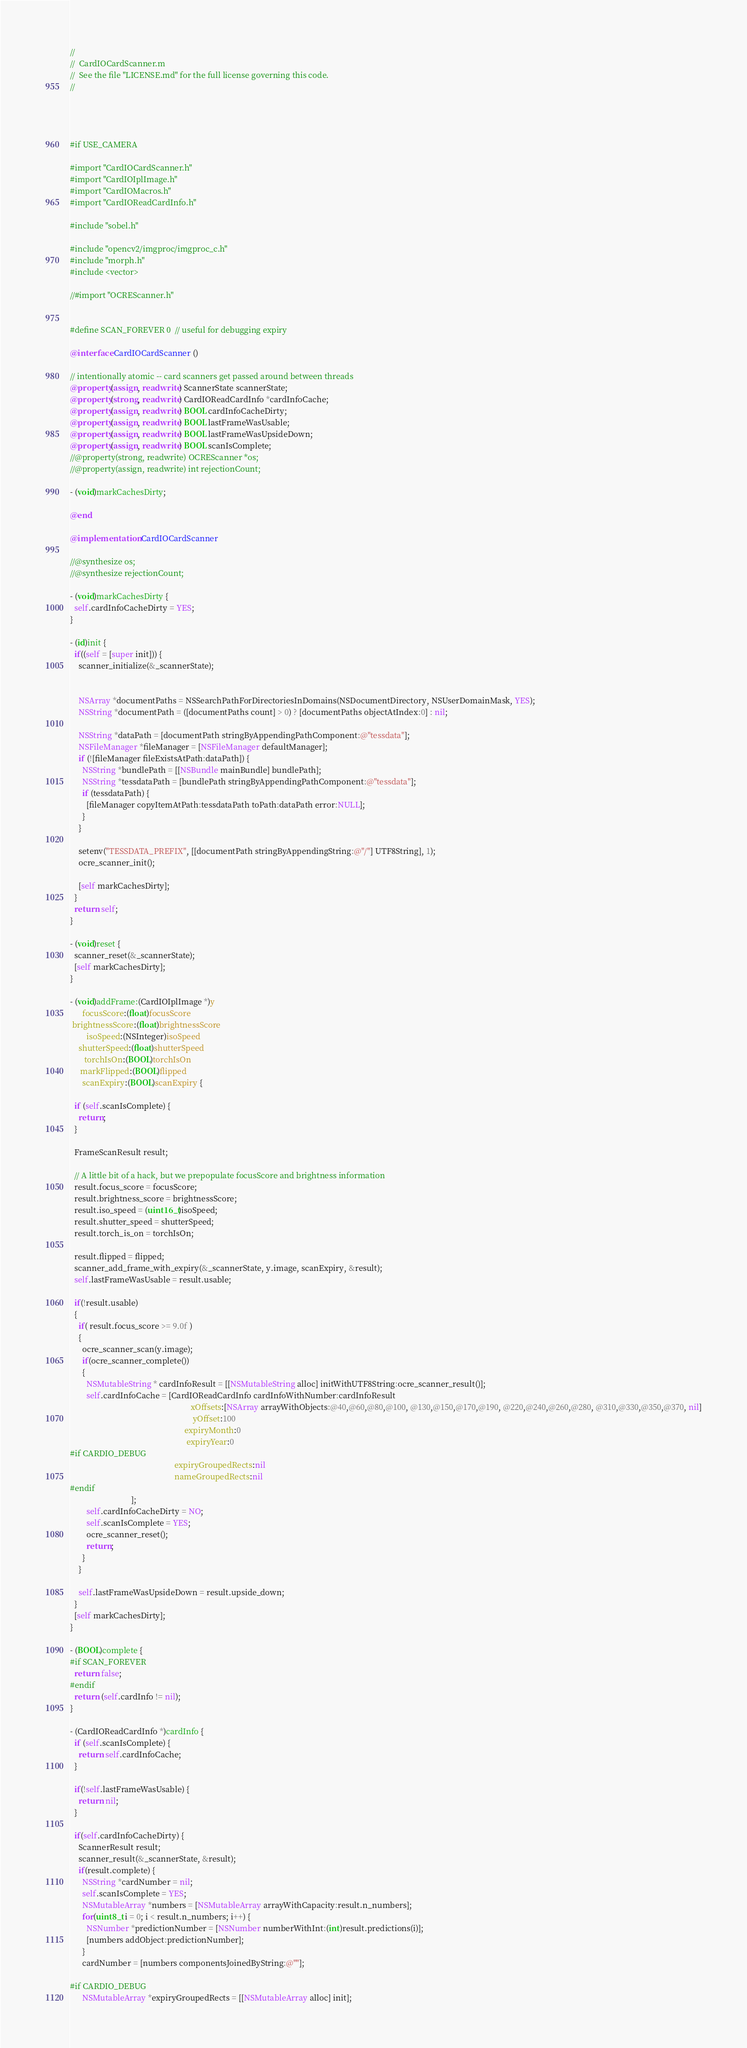Convert code to text. <code><loc_0><loc_0><loc_500><loc_500><_ObjectiveC_>//
//  CardIOCardScanner.m
//  See the file "LICENSE.md" for the full license governing this code.
//




#if USE_CAMERA

#import "CardIOCardScanner.h"
#import "CardIOIplImage.h"
#import "CardIOMacros.h"
#import "CardIOReadCardInfo.h"

#include "sobel.h"

#include "opencv2/imgproc/imgproc_c.h"
#include "morph.h"
#include <vector>

//#import "OCREScanner.h"


#define SCAN_FOREVER 0  // useful for debugging expiry

@interface CardIOCardScanner ()

// intentionally atomic -- card scanners get passed around between threads
@property(assign, readwrite) ScannerState scannerState;
@property(strong, readwrite) CardIOReadCardInfo *cardInfoCache;
@property(assign, readwrite) BOOL cardInfoCacheDirty;
@property(assign, readwrite) BOOL lastFrameWasUsable;
@property(assign, readwrite) BOOL lastFrameWasUpsideDown;
@property(assign, readwrite) BOOL scanIsComplete;
//@property(strong, readwrite) OCREScanner *os;
//@property(assign, readwrite) int rejectionCount;

- (void)markCachesDirty;

@end

@implementation CardIOCardScanner

//@synthesize os;
//@synthesize rejectionCount;

- (void)markCachesDirty {
  self.cardInfoCacheDirty = YES;
}

- (id)init {
  if((self = [super init])) {
    scanner_initialize(&_scannerState);


    NSArray *documentPaths = NSSearchPathForDirectoriesInDomains(NSDocumentDirectory, NSUserDomainMask, YES);
    NSString *documentPath = ([documentPaths count] > 0) ? [documentPaths objectAtIndex:0] : nil;
    
    NSString *dataPath = [documentPath stringByAppendingPathComponent:@"tessdata"];
    NSFileManager *fileManager = [NSFileManager defaultManager];
    if (![fileManager fileExistsAtPath:dataPath]) {
      NSString *bundlePath = [[NSBundle mainBundle] bundlePath];
      NSString *tessdataPath = [bundlePath stringByAppendingPathComponent:@"tessdata"];
      if (tessdataPath) {
        [fileManager copyItemAtPath:tessdataPath toPath:dataPath error:NULL];
      }
    }
    
    setenv("TESSDATA_PREFIX", [[documentPath stringByAppendingString:@"/"] UTF8String], 1);
    ocre_scanner_init();
    
    [self markCachesDirty];
  }
  return self;
}

- (void)reset {
  scanner_reset(&_scannerState);
  [self markCachesDirty];
}

- (void)addFrame:(CardIOIplImage *)y
      focusScore:(float)focusScore
 brightnessScore:(float)brightnessScore
        isoSpeed:(NSInteger)isoSpeed
    shutterSpeed:(float)shutterSpeed
       torchIsOn:(BOOL)torchIsOn
     markFlipped:(BOOL)flipped
      scanExpiry:(BOOL)scanExpiry {

  if (self.scanIsComplete) {
    return;
  }
  
  FrameScanResult result;
  
  // A little bit of a hack, but we prepopulate focusScore and brightness information
  result.focus_score = focusScore;
  result.brightness_score = brightnessScore;
  result.iso_speed = (uint16_t)isoSpeed;
  result.shutter_speed = shutterSpeed;
  result.torch_is_on = torchIsOn;
  
  result.flipped = flipped;
  scanner_add_frame_with_expiry(&_scannerState, y.image, scanExpiry, &result);
  self.lastFrameWasUsable = result.usable;
  
  if(!result.usable)
  {
    if( result.focus_score >= 9.0f )
    {
      ocre_scanner_scan(y.image);
      if(ocre_scanner_complete())
      {
        NSMutableString * cardInfoResult = [[NSMutableString alloc] initWithUTF8String:ocre_scanner_result()];
        self.cardInfoCache = [CardIOReadCardInfo cardInfoWithNumber:cardInfoResult
                                                           xOffsets:[NSArray arrayWithObjects:@40,@60,@80,@100, @130,@150,@170,@190, @220,@240,@260,@280, @310,@330,@350,@370, nil]
                                                            yOffset:100
                                                        expiryMonth:0
                                                         expiryYear:0
#if CARDIO_DEBUG
                                                   expiryGroupedRects:nil
                                                   nameGroupedRects:nil
#endif
                              ];
        self.cardInfoCacheDirty = NO;
        self.scanIsComplete = YES;
        ocre_scanner_reset();
        return;
      }
    }
    
    self.lastFrameWasUpsideDown = result.upside_down;
  }
  [self markCachesDirty];
}

- (BOOL)complete {
#if SCAN_FOREVER
  return false;
#endif
  return (self.cardInfo != nil);
}

- (CardIOReadCardInfo *)cardInfo {
  if (self.scanIsComplete) {
    return self.cardInfoCache;
  }
  
  if(!self.lastFrameWasUsable) {
    return nil;
  }

  if(self.cardInfoCacheDirty) {
    ScannerResult result;
    scanner_result(&_scannerState, &result);
    if(result.complete) {
      NSString *cardNumber = nil;
      self.scanIsComplete = YES;
      NSMutableArray *numbers = [NSMutableArray arrayWithCapacity:result.n_numbers];
      for(uint8_t i = 0; i < result.n_numbers; i++) {
        NSNumber *predictionNumber = [NSNumber numberWithInt:(int)result.predictions(i)];
        [numbers addObject:predictionNumber];
      }
      cardNumber = [numbers componentsJoinedByString:@""];

#if CARDIO_DEBUG
      NSMutableArray *expiryGroupedRects = [[NSMutableArray alloc] init];</code> 